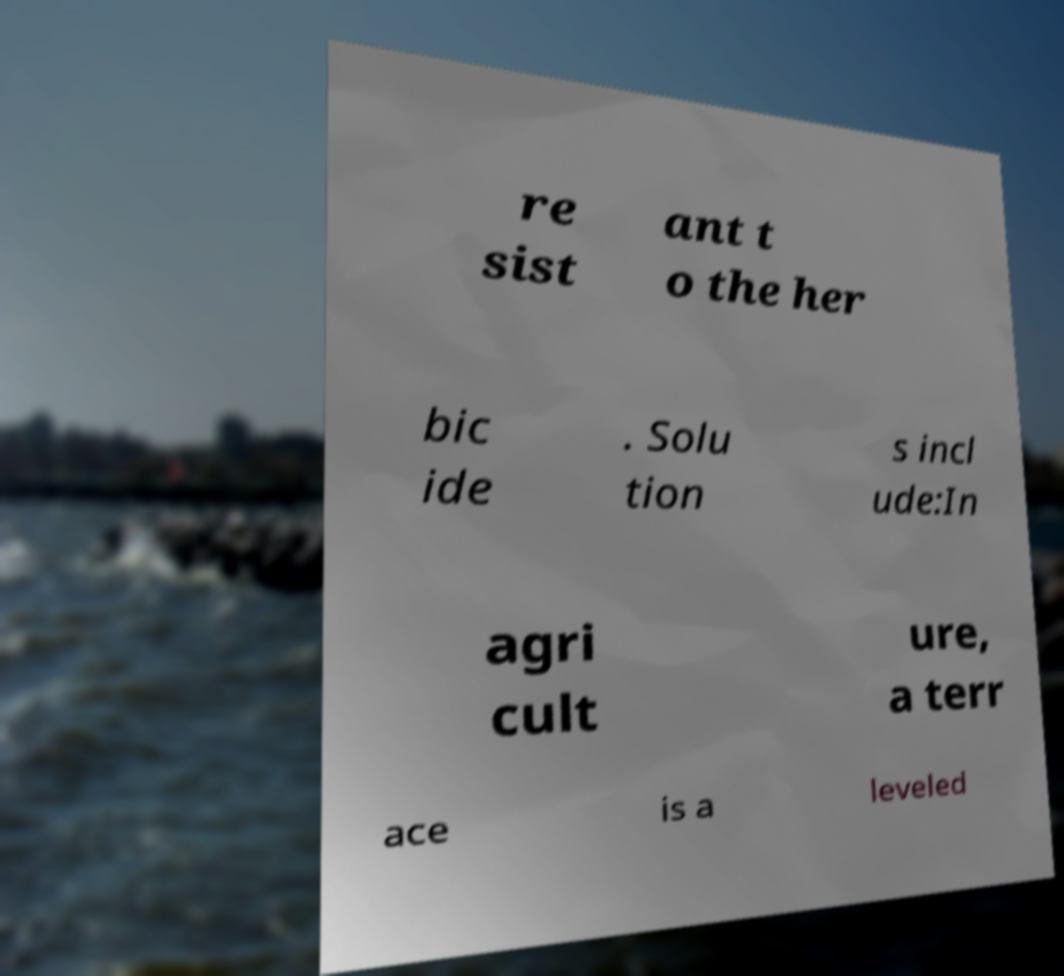There's text embedded in this image that I need extracted. Can you transcribe it verbatim? re sist ant t o the her bic ide . Solu tion s incl ude:In agri cult ure, a terr ace is a leveled 